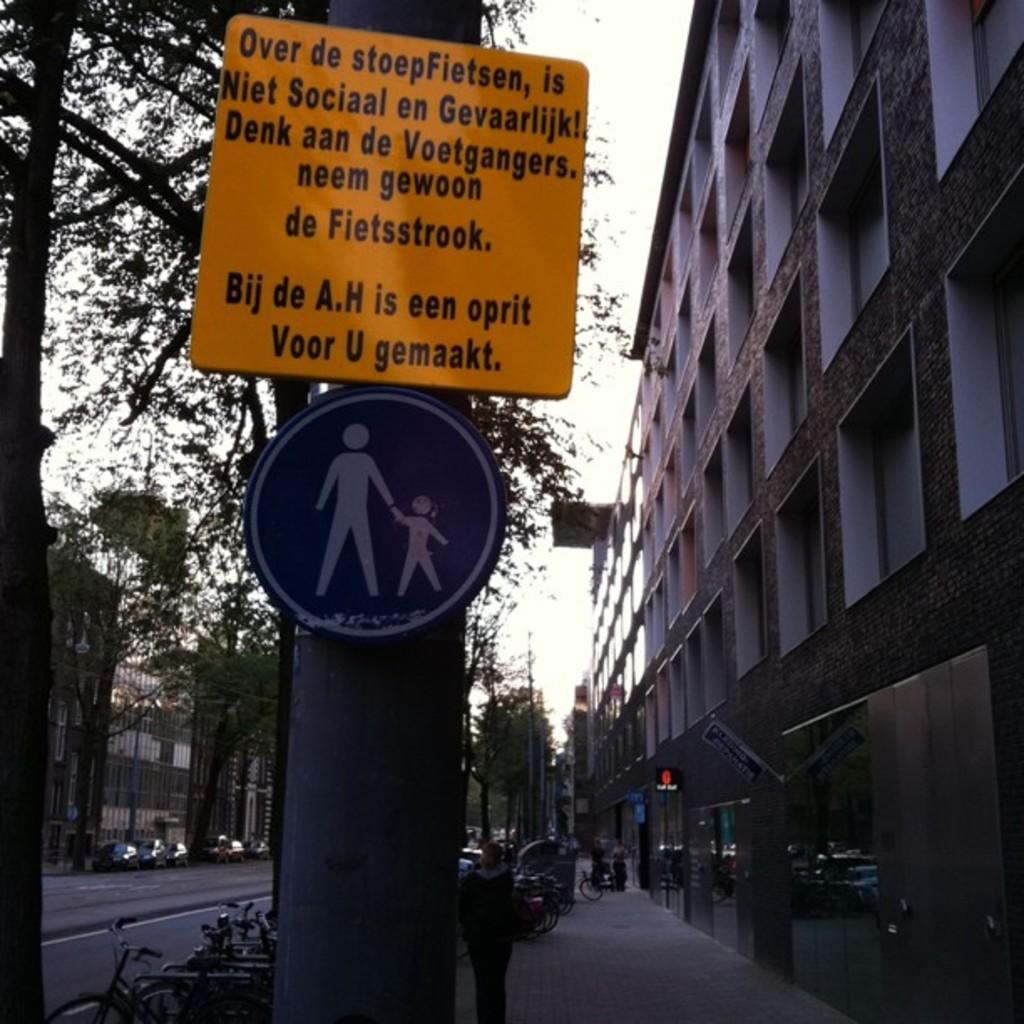<image>
Provide a brief description of the given image. A yellow sign says "Voor U gemaakt" on the bottom line of writing. 